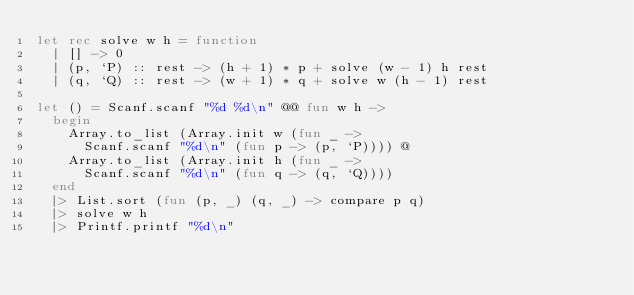<code> <loc_0><loc_0><loc_500><loc_500><_OCaml_>let rec solve w h = function
  | [] -> 0
  | (p, `P) :: rest -> (h + 1) * p + solve (w - 1) h rest
  | (q, `Q) :: rest -> (w + 1) * q + solve w (h - 1) rest

let () = Scanf.scanf "%d %d\n" @@ fun w h ->
  begin
    Array.to_list (Array.init w (fun _ ->
      Scanf.scanf "%d\n" (fun p -> (p, `P)))) @
    Array.to_list (Array.init h (fun _ ->
      Scanf.scanf "%d\n" (fun q -> (q, `Q))))
  end
  |> List.sort (fun (p, _) (q, _) -> compare p q)
  |> solve w h
  |> Printf.printf "%d\n"

</code> 